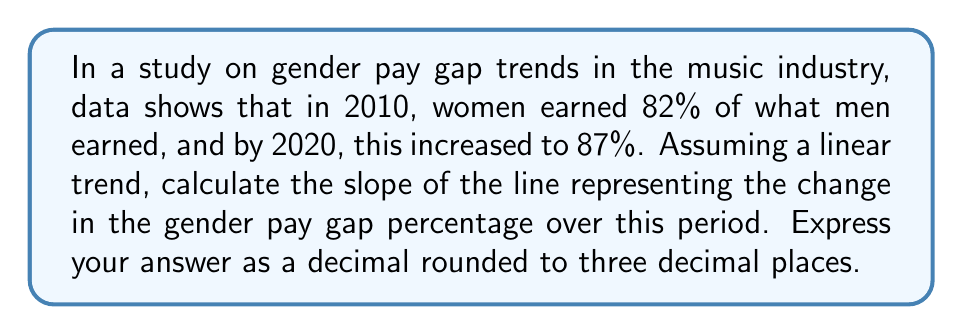What is the answer to this math problem? To find the slope of the line, we'll use the slope formula:

$$ m = \frac{y_2 - y_1}{x_2 - x_1} $$

Where:
$(x_1, y_1)$ is the point for 2010: $(2010, 82)$
$(x_2, y_2)$ is the point for 2020: $(2020, 87)$

Step 1: Plug the values into the slope formula:

$$ m = \frac{87 - 82}{2020 - 2010} $$

Step 2: Simplify the numerator and denominator:

$$ m = \frac{5}{10} $$

Step 3: Divide to get the decimal form:

$$ m = 0.5 $$

This means the gender pay gap percentage increased by 0.5 percentage points per year on average.

Step 4: Round to three decimal places:

$$ m = 0.500 $$
Answer: $0.500$ 